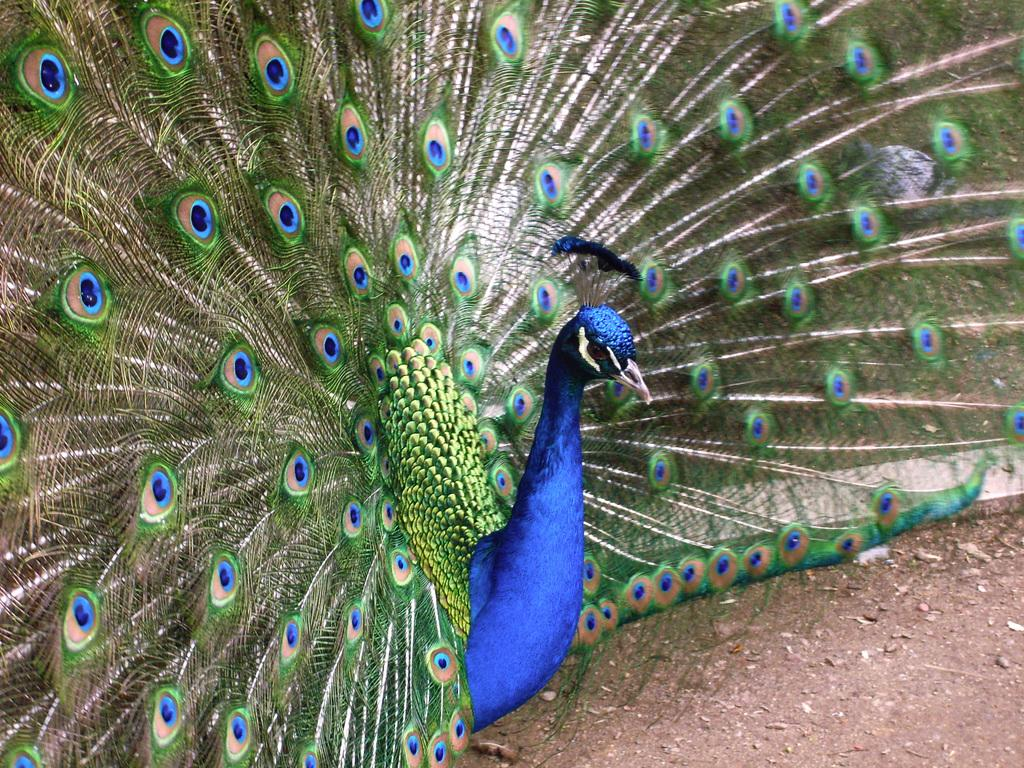What type of bird is in the image? There is a peacock in the image. What colors can be seen on the peacock? The peacock is in blue and green colors. Where is the peacock located in the image? The peacock is on the ground. What type of boundary can be seen in the image? There is no boundary present in the image; it features a peacock on the ground. How many geese are visible in the image? There are no geese present in the image. 